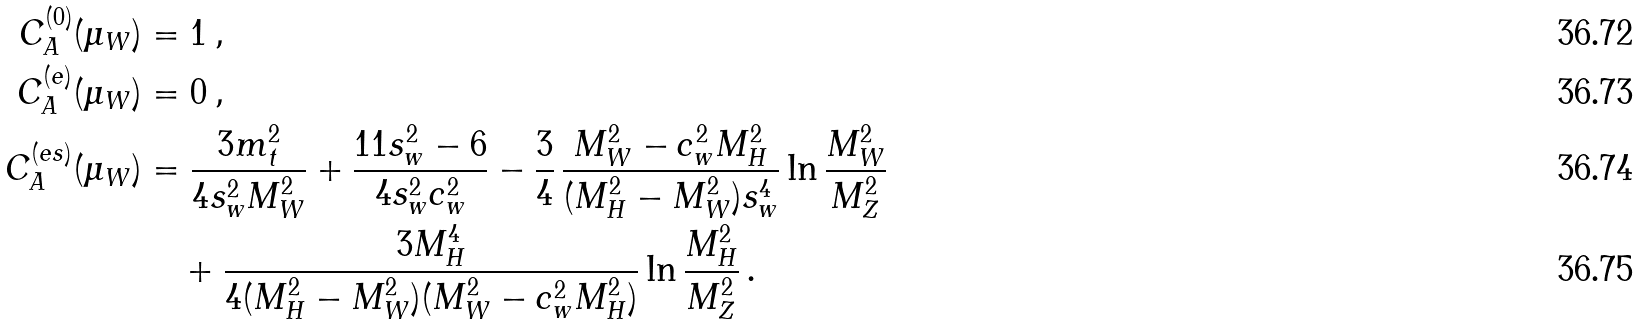Convert formula to latex. <formula><loc_0><loc_0><loc_500><loc_500>C _ { A } ^ { ( 0 ) } ( \mu _ { W } ) & = 1 \, , \\ C _ { A } ^ { ( e ) } ( \mu _ { W } ) & = 0 \, , \\ C _ { A } ^ { ( e s ) } ( \mu _ { W } ) & = \frac { 3 m _ { t } ^ { 2 } } { 4 s _ { w } ^ { 2 } M _ { W } ^ { 2 } } + \frac { 1 1 s _ { w } ^ { 2 } - 6 } { 4 s _ { w } ^ { 2 } c _ { w } ^ { 2 } } - \frac { 3 } { 4 } \, \frac { M _ { W } ^ { 2 } - c _ { w } ^ { 2 } M _ { H } ^ { 2 } } { ( M _ { H } ^ { 2 } - M _ { W } ^ { 2 } ) s _ { w } ^ { 4 } } \ln { \frac { M _ { W } ^ { 2 } } { M _ { Z } ^ { 2 } } } \\ & \quad + \frac { 3 M _ { H } ^ { 4 } } { 4 ( M _ { H } ^ { 2 } - M _ { W } ^ { 2 } ) ( M _ { W } ^ { 2 } - c _ { w } ^ { 2 } M _ { H } ^ { 2 } ) } \ln { \frac { M _ { H } ^ { 2 } } { M _ { Z } ^ { 2 } } } \, .</formula> 